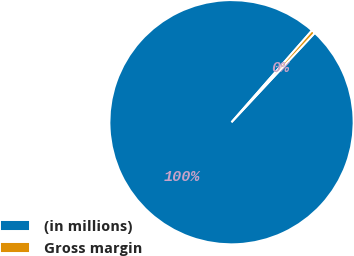<chart> <loc_0><loc_0><loc_500><loc_500><pie_chart><fcel>(in millions)<fcel>Gross margin<nl><fcel>99.51%<fcel>0.49%<nl></chart> 